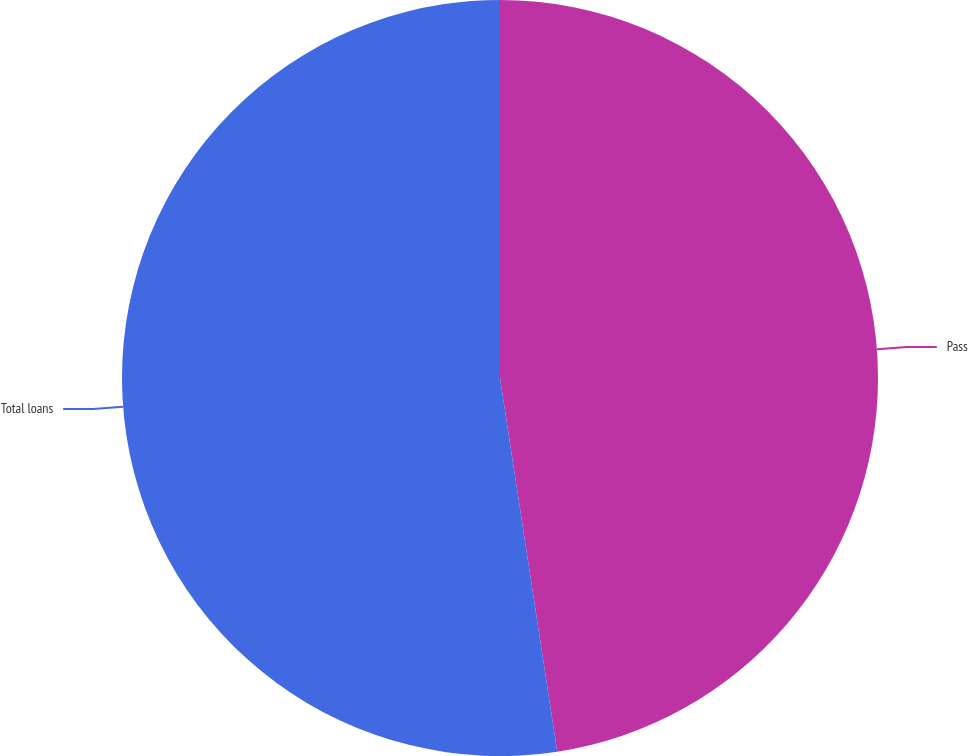Convert chart to OTSL. <chart><loc_0><loc_0><loc_500><loc_500><pie_chart><fcel>Pass<fcel>Total loans<nl><fcel>47.58%<fcel>52.42%<nl></chart> 